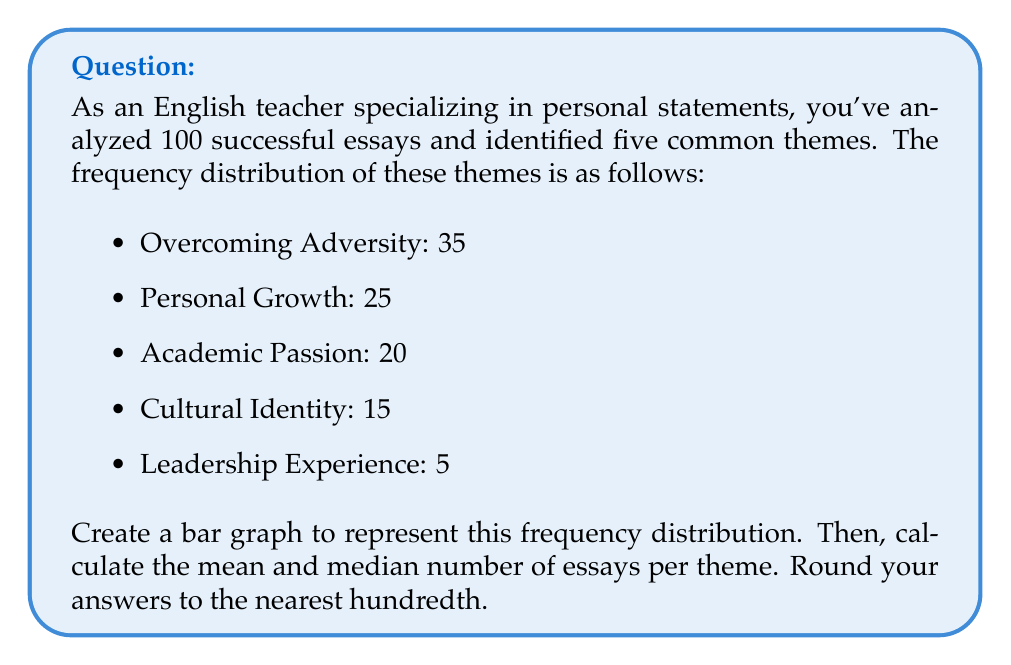Show me your answer to this math problem. 1. First, let's create the bar graph using Asymptote:

[asy]
import graph;
size(200,150);

string[] themes = {"Overcoming Adversity", "Personal Growth", "Academic Passion", "Cultural Identity", "Leadership Experience"};
real[] frequencies = {35, 25, 20, 15, 5};

for(int i=0; i < 5; ++i) {
  fill(shift(i,0)*unitsquare, paleblue);
  draw(shift(i,0)*unitsquare^^shift(i,frequencies[i])*unitsquare, black);
}

xaxis("Themes", BottomTop, TickLabels(rotate(90)*Label(), themes));
yaxis("Frequency", LeftRight, RightTicks);

label("Frequency Distribution of Common Themes", point(2.5,40));
[/asy]

2. To calculate the mean, we use the formula:

$$ \text{Mean} = \frac{\sum_{i=1}^{n} x_i}{n} $$

Where $x_i$ are the individual frequencies and $n$ is the number of themes.

$$ \text{Mean} = \frac{35 + 25 + 20 + 15 + 5}{5} = \frac{100}{5} = 20 $$

3. To find the median, we first order the frequencies from lowest to highest:

5, 15, 20, 25, 35

Since there are an odd number of values, the median is the middle value.

$$ \text{Median} = 20 $$

Both the mean and median are already whole numbers, so no rounding is necessary.
Answer: Mean: 20, Median: 20 